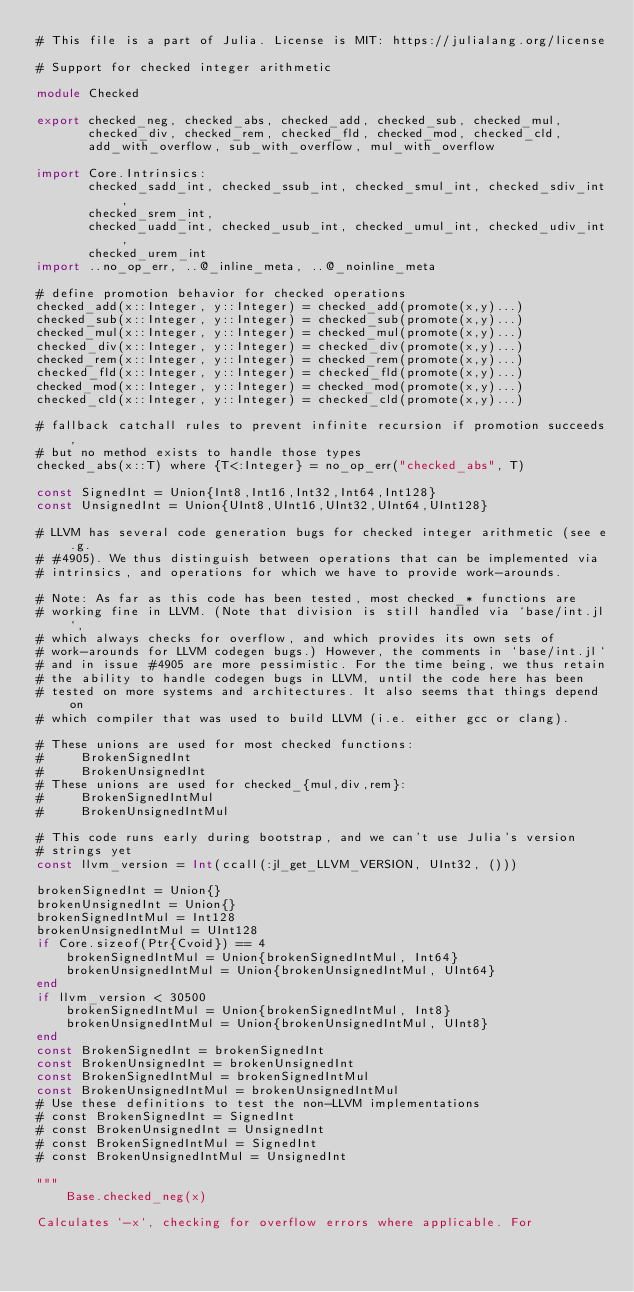<code> <loc_0><loc_0><loc_500><loc_500><_Julia_># This file is a part of Julia. License is MIT: https://julialang.org/license

# Support for checked integer arithmetic

module Checked

export checked_neg, checked_abs, checked_add, checked_sub, checked_mul,
       checked_div, checked_rem, checked_fld, checked_mod, checked_cld,
       add_with_overflow, sub_with_overflow, mul_with_overflow

import Core.Intrinsics:
       checked_sadd_int, checked_ssub_int, checked_smul_int, checked_sdiv_int,
       checked_srem_int,
       checked_uadd_int, checked_usub_int, checked_umul_int, checked_udiv_int,
       checked_urem_int
import ..no_op_err, ..@_inline_meta, ..@_noinline_meta

# define promotion behavior for checked operations
checked_add(x::Integer, y::Integer) = checked_add(promote(x,y)...)
checked_sub(x::Integer, y::Integer) = checked_sub(promote(x,y)...)
checked_mul(x::Integer, y::Integer) = checked_mul(promote(x,y)...)
checked_div(x::Integer, y::Integer) = checked_div(promote(x,y)...)
checked_rem(x::Integer, y::Integer) = checked_rem(promote(x,y)...)
checked_fld(x::Integer, y::Integer) = checked_fld(promote(x,y)...)
checked_mod(x::Integer, y::Integer) = checked_mod(promote(x,y)...)
checked_cld(x::Integer, y::Integer) = checked_cld(promote(x,y)...)

# fallback catchall rules to prevent infinite recursion if promotion succeeds,
# but no method exists to handle those types
checked_abs(x::T) where {T<:Integer} = no_op_err("checked_abs", T)

const SignedInt = Union{Int8,Int16,Int32,Int64,Int128}
const UnsignedInt = Union{UInt8,UInt16,UInt32,UInt64,UInt128}

# LLVM has several code generation bugs for checked integer arithmetic (see e.g.
# #4905). We thus distinguish between operations that can be implemented via
# intrinsics, and operations for which we have to provide work-arounds.

# Note: As far as this code has been tested, most checked_* functions are
# working fine in LLVM. (Note that division is still handled via `base/int.jl`,
# which always checks for overflow, and which provides its own sets of
# work-arounds for LLVM codegen bugs.) However, the comments in `base/int.jl`
# and in issue #4905 are more pessimistic. For the time being, we thus retain
# the ability to handle codegen bugs in LLVM, until the code here has been
# tested on more systems and architectures. It also seems that things depend on
# which compiler that was used to build LLVM (i.e. either gcc or clang).

# These unions are used for most checked functions:
#     BrokenSignedInt
#     BrokenUnsignedInt
# These unions are used for checked_{mul,div,rem}:
#     BrokenSignedIntMul
#     BrokenUnsignedIntMul

# This code runs early during bootstrap, and we can't use Julia's version
# strings yet
const llvm_version = Int(ccall(:jl_get_LLVM_VERSION, UInt32, ()))

brokenSignedInt = Union{}
brokenUnsignedInt = Union{}
brokenSignedIntMul = Int128
brokenUnsignedIntMul = UInt128
if Core.sizeof(Ptr{Cvoid}) == 4
    brokenSignedIntMul = Union{brokenSignedIntMul, Int64}
    brokenUnsignedIntMul = Union{brokenUnsignedIntMul, UInt64}
end
if llvm_version < 30500
    brokenSignedIntMul = Union{brokenSignedIntMul, Int8}
    brokenUnsignedIntMul = Union{brokenUnsignedIntMul, UInt8}
end
const BrokenSignedInt = brokenSignedInt
const BrokenUnsignedInt = brokenUnsignedInt
const BrokenSignedIntMul = brokenSignedIntMul
const BrokenUnsignedIntMul = brokenUnsignedIntMul
# Use these definitions to test the non-LLVM implementations
# const BrokenSignedInt = SignedInt
# const BrokenUnsignedInt = UnsignedInt
# const BrokenSignedIntMul = SignedInt
# const BrokenUnsignedIntMul = UnsignedInt

"""
    Base.checked_neg(x)

Calculates `-x`, checking for overflow errors where applicable. For</code> 